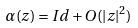<formula> <loc_0><loc_0><loc_500><loc_500>\alpha ( z ) = I d + O ( | z | ^ { 2 } )</formula> 